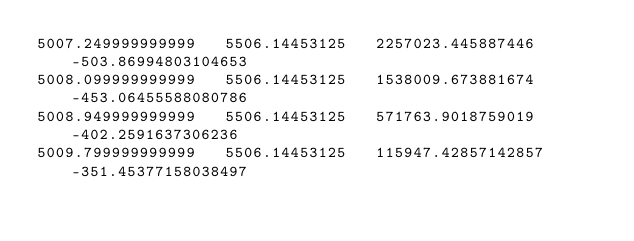<code> <loc_0><loc_0><loc_500><loc_500><_SQL_>5007.249999999999	5506.14453125	2257023.445887446	-503.86994803104653
5008.099999999999	5506.14453125	1538009.673881674	-453.06455588080786
5008.949999999999	5506.14453125	571763.9018759019	-402.2591637306236
5009.799999999999	5506.14453125	115947.42857142857	-351.45377158038497</code> 